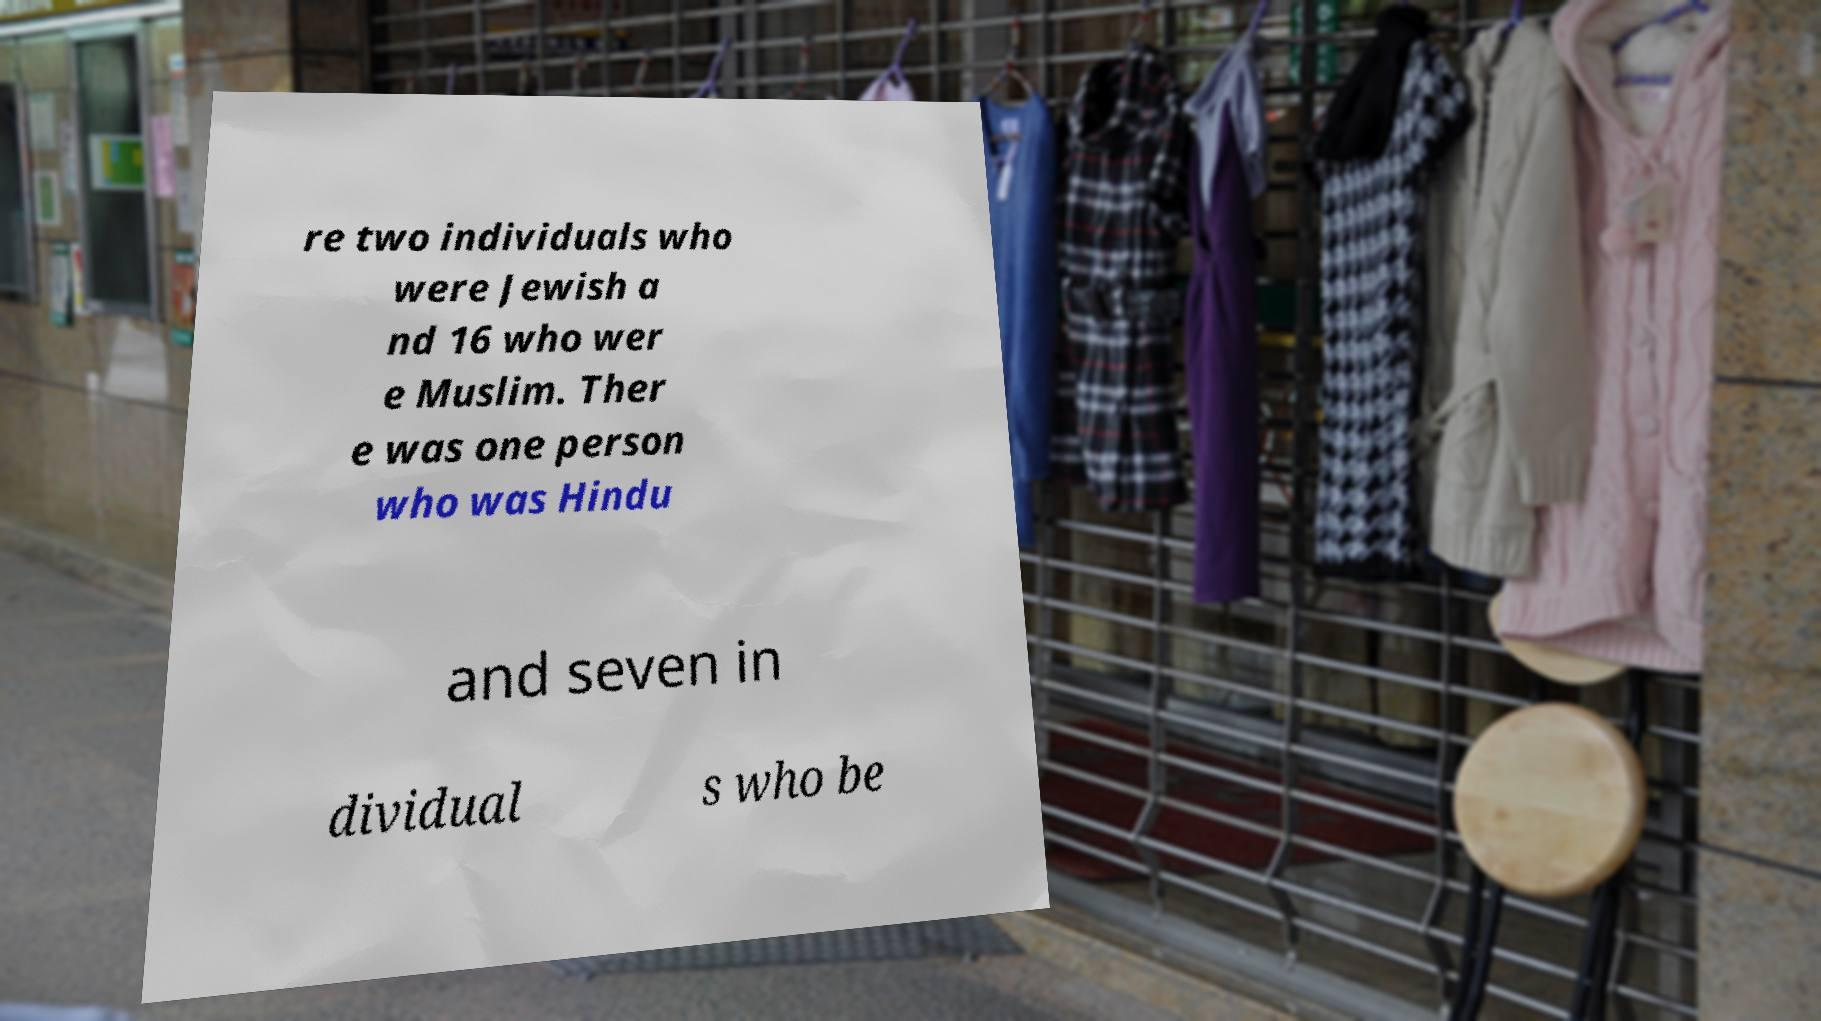Could you assist in decoding the text presented in this image and type it out clearly? re two individuals who were Jewish a nd 16 who wer e Muslim. Ther e was one person who was Hindu and seven in dividual s who be 